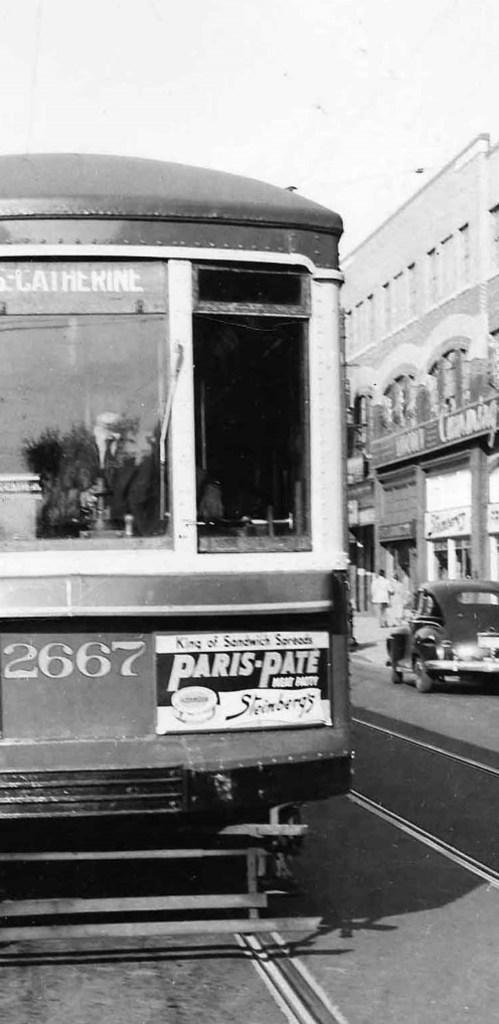What is the color scheme of the image? The image is black and white. What mode of transportation can be seen in the image? There is a train in the image. What other type of vehicle is present in the image? There is a car in the image. What type of structure is visible in the image? There is a building in the image. Are there any human figures in the image? Yes, there are people visible in the image. What architectural feature can be seen in the image? There are windows in the image. What part of the natural environment is visible in the image? The sky is visible in the image. What type of coat is the train wearing in the image? Trains do not wear coats, as they are inanimate objects. 